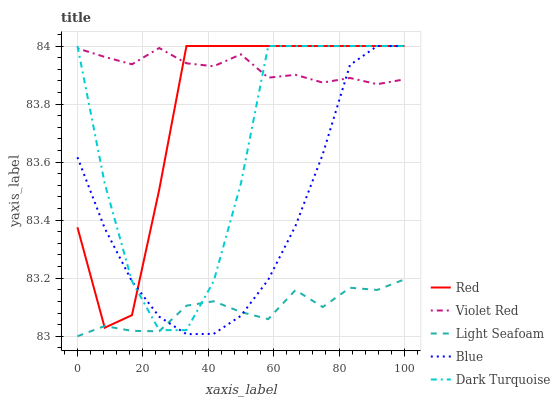Does Light Seafoam have the minimum area under the curve?
Answer yes or no. Yes. Does Violet Red have the maximum area under the curve?
Answer yes or no. Yes. Does Dark Turquoise have the minimum area under the curve?
Answer yes or no. No. Does Dark Turquoise have the maximum area under the curve?
Answer yes or no. No. Is Violet Red the smoothest?
Answer yes or no. Yes. Is Dark Turquoise the roughest?
Answer yes or no. Yes. Is Dark Turquoise the smoothest?
Answer yes or no. No. Is Violet Red the roughest?
Answer yes or no. No. Does Light Seafoam have the lowest value?
Answer yes or no. Yes. Does Dark Turquoise have the lowest value?
Answer yes or no. No. Does Red have the highest value?
Answer yes or no. Yes. Does Violet Red have the highest value?
Answer yes or no. No. Is Light Seafoam less than Violet Red?
Answer yes or no. Yes. Is Violet Red greater than Light Seafoam?
Answer yes or no. Yes. Does Dark Turquoise intersect Violet Red?
Answer yes or no. Yes. Is Dark Turquoise less than Violet Red?
Answer yes or no. No. Is Dark Turquoise greater than Violet Red?
Answer yes or no. No. Does Light Seafoam intersect Violet Red?
Answer yes or no. No. 